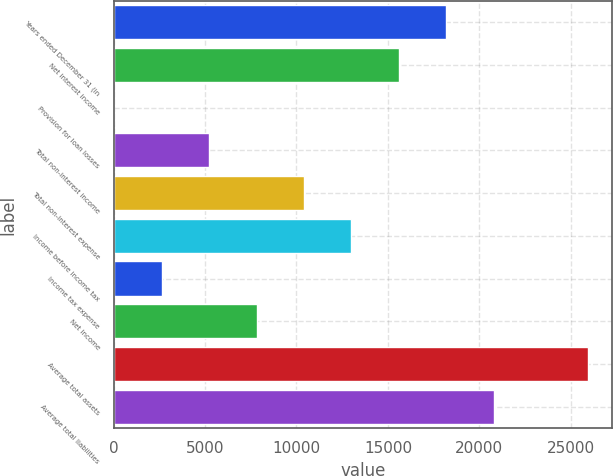<chart> <loc_0><loc_0><loc_500><loc_500><bar_chart><fcel>Years ended December 31 (in<fcel>Net interest income<fcel>Provision for loan losses<fcel>Total non-interest income<fcel>Total non-interest expense<fcel>Income before income tax<fcel>Income tax expense<fcel>Net income<fcel>Average total assets<fcel>Average total liabilities<nl><fcel>18181.3<fcel>15589.5<fcel>38.7<fcel>5222.3<fcel>10405.9<fcel>12997.7<fcel>2630.5<fcel>7814.1<fcel>25956.7<fcel>20773.1<nl></chart> 